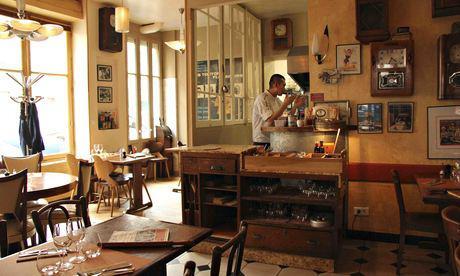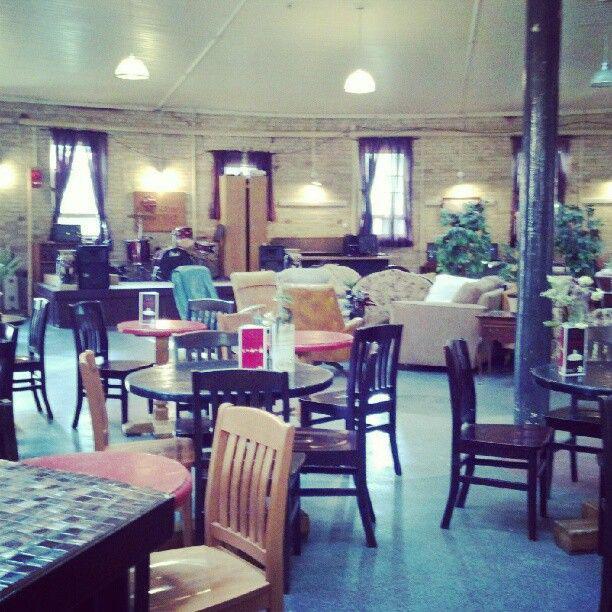The first image is the image on the left, the second image is the image on the right. For the images shown, is this caption "One image shows an interior with a black column in the center, dome-shaped suspended lights, and paned square windows in the ceiling." true? Answer yes or no. No. The first image is the image on the left, the second image is the image on the right. Considering the images on both sides, is "There are both bar stools and chairs." valid? Answer yes or no. No. 